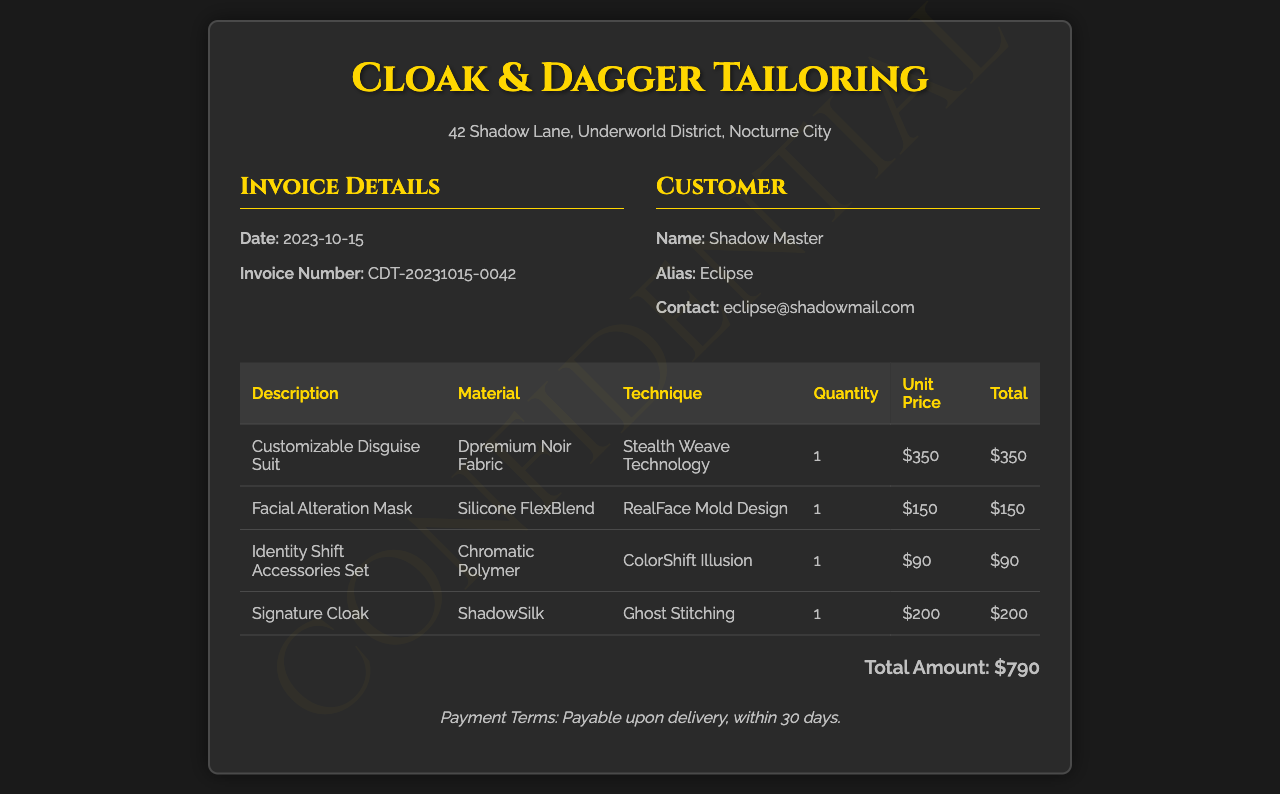What is the invoice number? The invoice number is uniquely assigned to this specific transaction and can be found in the invoice details section.
Answer: CDT-20231015-0042 What is the total amount charged? The total amount charged is calculated by summing all the item totals listed in the invoice.
Answer: $790 What is the date of the invoice? The date of the invoice indicates when the services were billed, found in the invoice details.
Answer: 2023-10-15 Who is the customer? The customer details section lists the name of the person or entity receiving the service.
Answer: Shadow Master What is the material used for the customizable disguise suit? The material is specified in the item description of the invoice, showing what material was used for the product.
Answer: Dpremium Noir Fabric What is the payment term specified? The payment term indicates when the payment is due based on the delivery date of the service, typically mentioned at the bottom of the invoice.
Answer: Payable upon delivery, within 30 days What technique was used for the signature cloak? The technique used is noted for each item, describing how it was created or designed.
Answer: Ghost Stitching Which item is the most expensive? Identifying the item with the highest price from the list of items in the invoice indicates the costliest service or product.
Answer: Customizable Disguise Suit What is the material of the facial alteration mask? The material specified helps understand the composition of a particular item on the invoice.
Answer: Silicone FlexBlend 